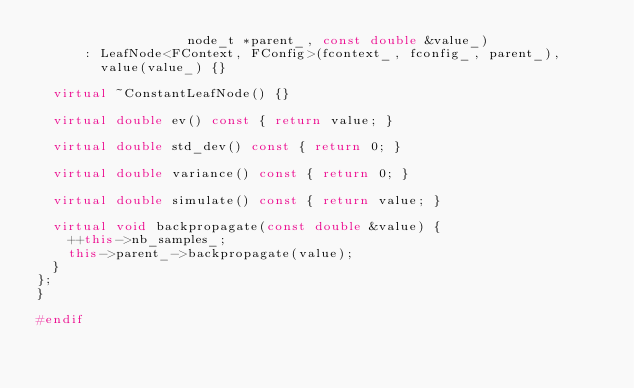Convert code to text. <code><loc_0><loc_0><loc_500><loc_500><_C++_>                   node_t *parent_, const double &value_)
      : LeafNode<FContext, FConfig>(fcontext_, fconfig_, parent_),
        value(value_) {}

  virtual ~ConstantLeafNode() {}

  virtual double ev() const { return value; }

  virtual double std_dev() const { return 0; }

  virtual double variance() const { return 0; }

  virtual double simulate() const { return value; }

  virtual void backpropagate(const double &value) {
    ++this->nb_samples_;
    this->parent_->backpropagate(value);
  }
};
}

#endif
</code> 